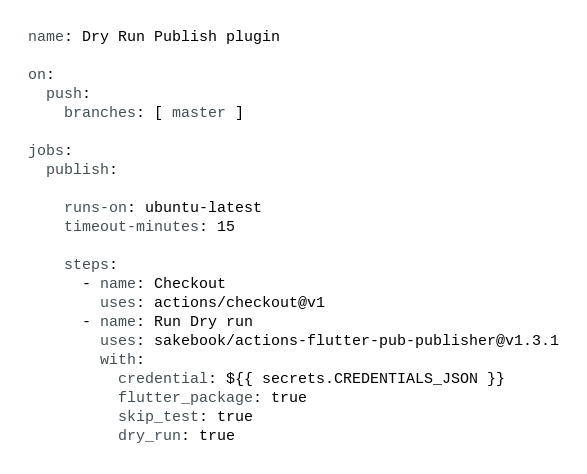Convert code to text. <code><loc_0><loc_0><loc_500><loc_500><_YAML_>name: Dry Run Publish plugin

on:
  push:
    branches: [ master ]

jobs:
  publish:

    runs-on: ubuntu-latest
    timeout-minutes: 15

    steps:
      - name: Checkout
        uses: actions/checkout@v1
      - name: Run Dry run
        uses: sakebook/actions-flutter-pub-publisher@v1.3.1
        with:
          credential: ${{ secrets.CREDENTIALS_JSON }}
          flutter_package: true
          skip_test: true
          dry_run: true</code> 